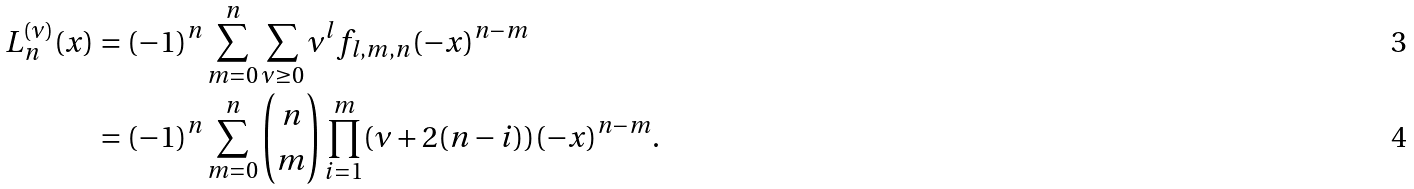Convert formula to latex. <formula><loc_0><loc_0><loc_500><loc_500>L ^ { ( \nu ) } _ { n } ( x ) & = ( - 1 ) ^ { n } \sum _ { m = 0 } ^ { n } \sum _ { \nu \geq 0 } \nu ^ { l } f _ { l , m , n } ( - x ) ^ { n - m } \\ & = ( - 1 ) ^ { n } \sum _ { m = 0 } ^ { n } { n \choose m } \prod _ { i = 1 } ^ { m } ( \nu + 2 ( n - i ) ) ( - x ) ^ { n - m } .</formula> 